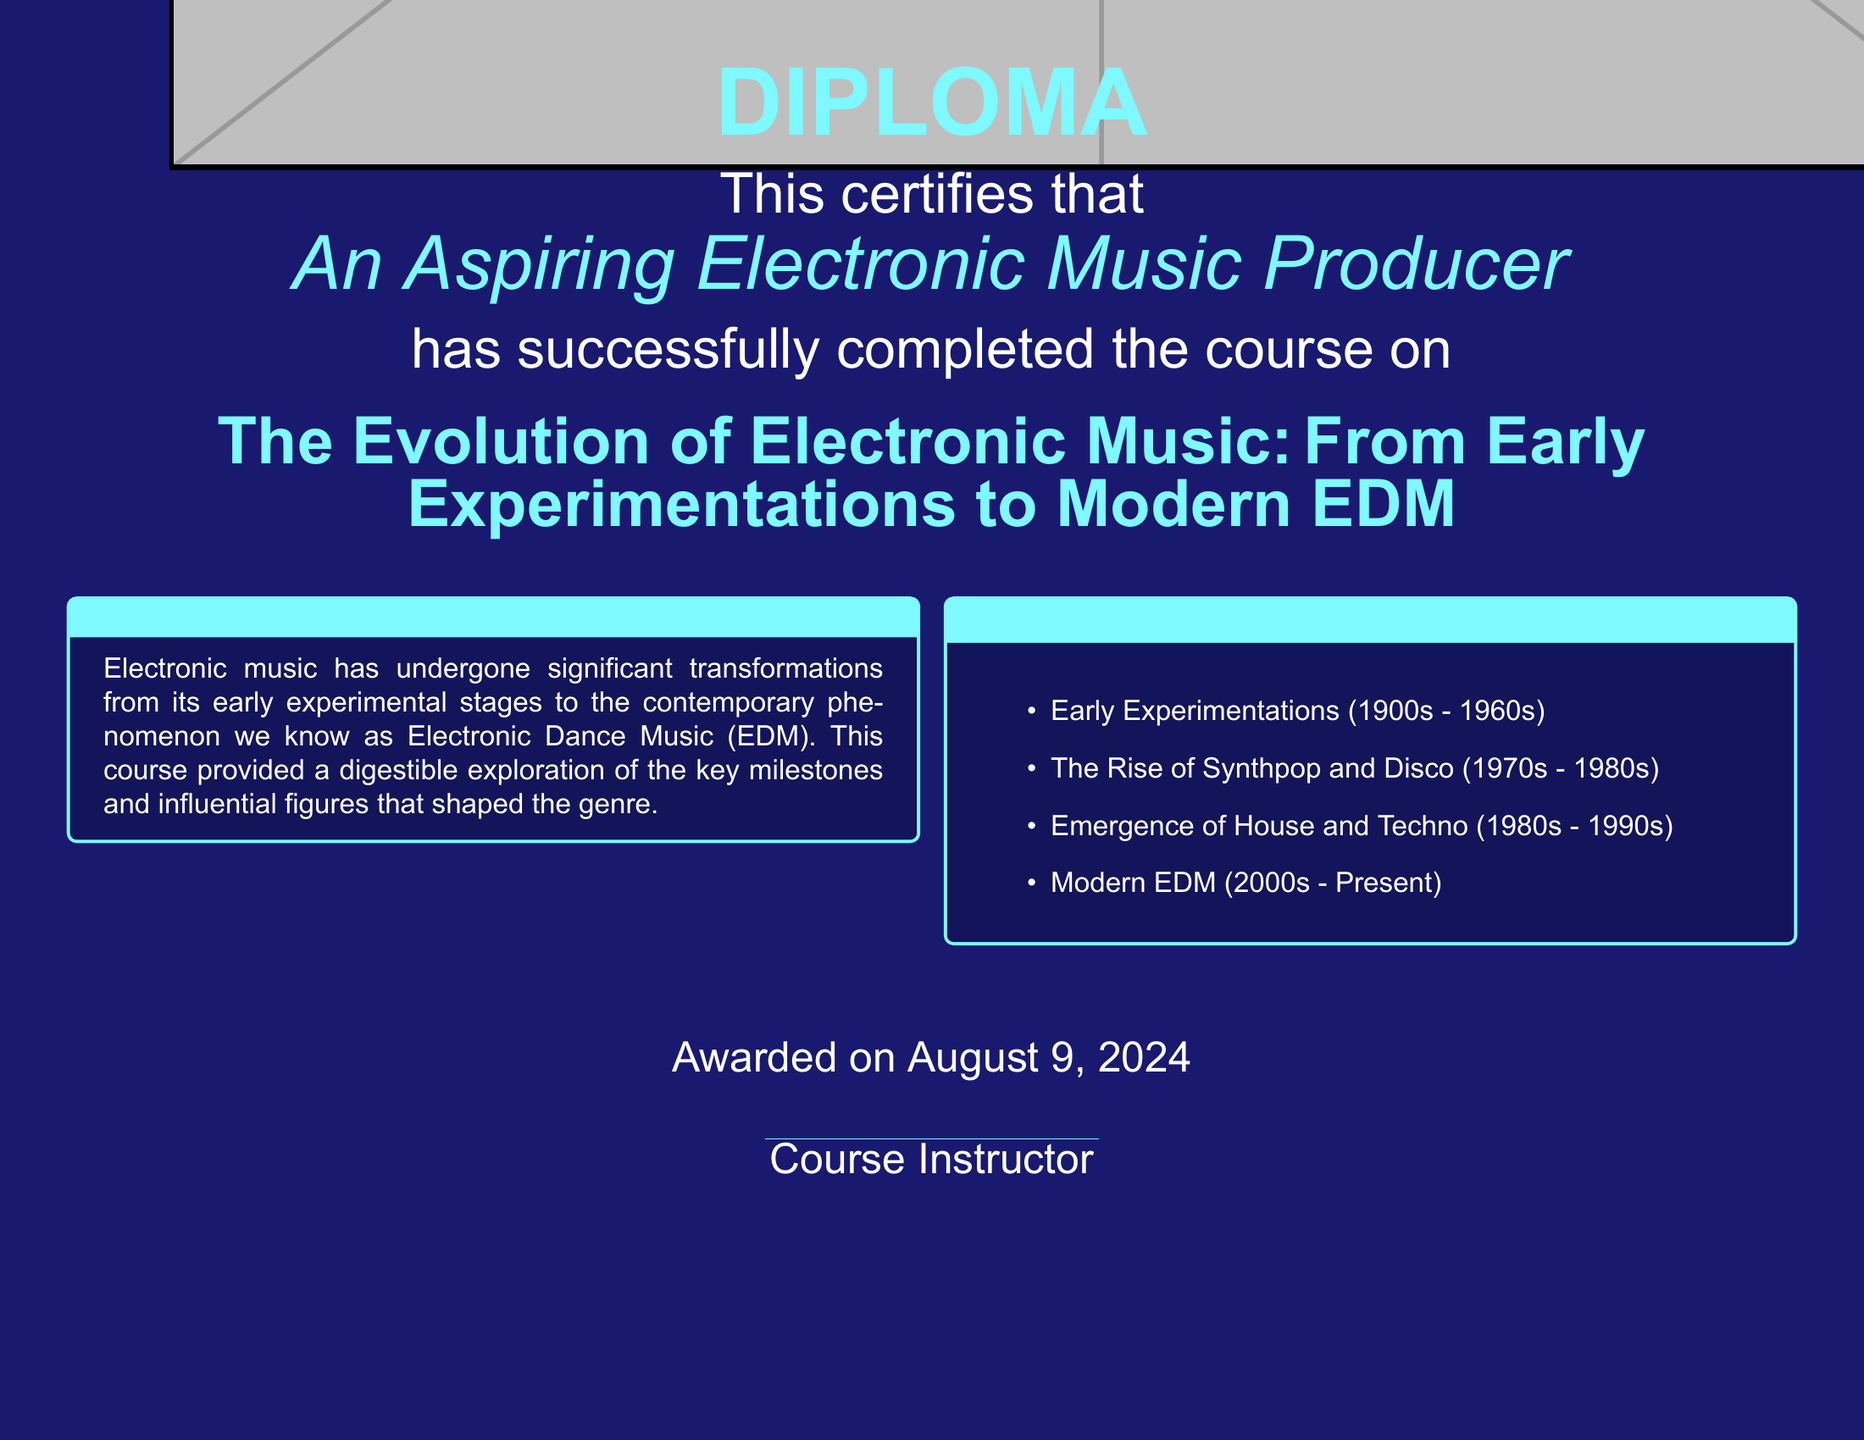What is the title of the course? The title is mentioned prominently in the document, specifying the course's focus on electronic music's evolution.
Answer: The Evolution of Electronic Music: From Early Experimentations to Modern EDM Who is the recipient of the diploma? The diploma states the recipient's title as an aspiring producer, making it clear who completed the course.
Answer: An Aspiring Electronic Music Producer What is the awarded date shown on the diploma? The diploma specifies the awarded date simply as today's date, indicating when the course completion was recognized.
Answer: Today What color is used for the course title? The document provides information about the colors used, indicating specific colors for different sections, including the course title.
Answer: Electric blue How many key topics are covered in the course? The document lists the key topics covered in the course, allowing us to determine their total count.
Answer: Four What time period marks the early experimentations in electronic music? The timeframe is mentioned in the document specifically regarding the early stages of electronic music.
Answer: 1900s - 1960s Which genres emerged during the 1980s-1990s according to the document? The document discusses significant genres that came up in the specified time frame, highlighting important movements in electronic music.
Answer: House and Techno What is the overall theme of the course? The course overview provides insights into the general theme and focus of the curriculum.
Answer: Transformation of electronic music 